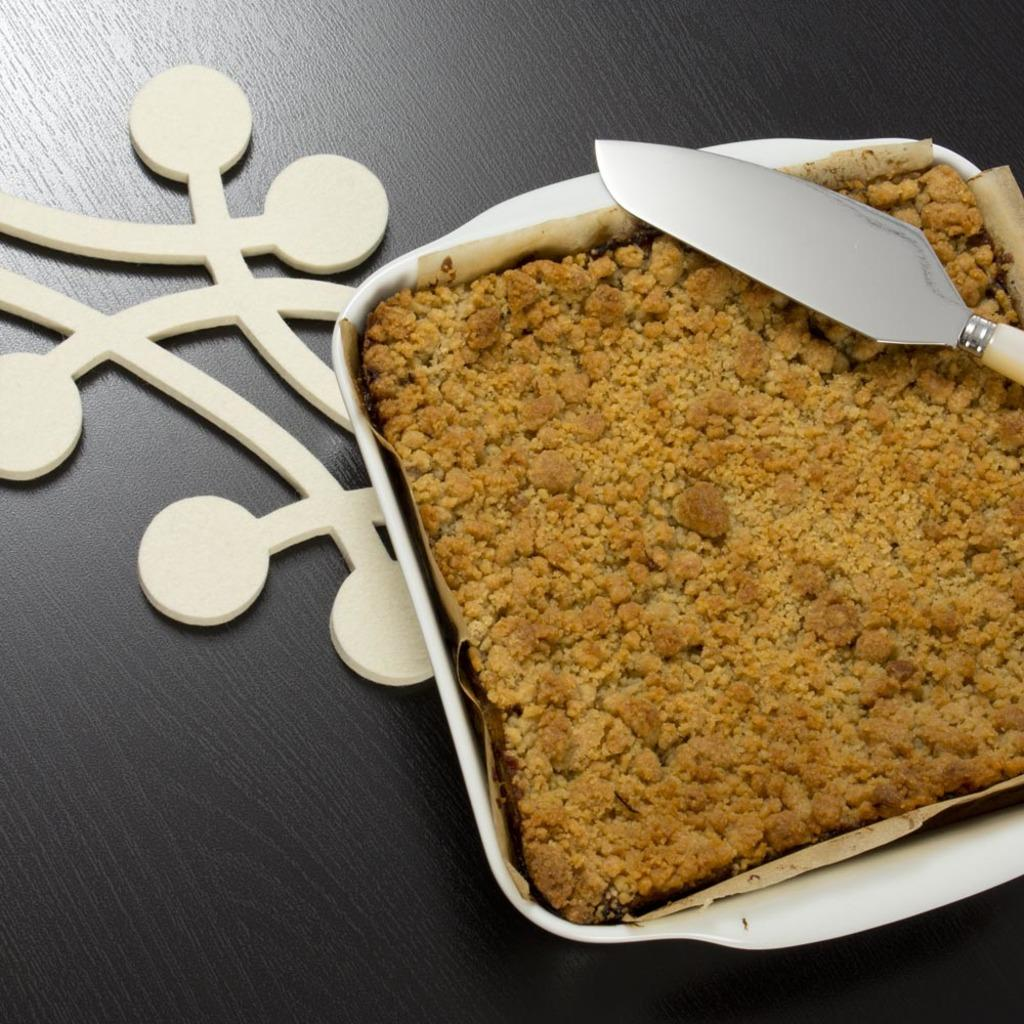What type of surface is visible in the image? There is a wooden surface in the image. What is on the wooden surface? There is a bowl with food and a knife on the wooden surface. How many children are playing with the spark on the wooden surface in the image? There are no children or sparks present in the image; it only features a wooden surface with a bowl of food and a knife. 